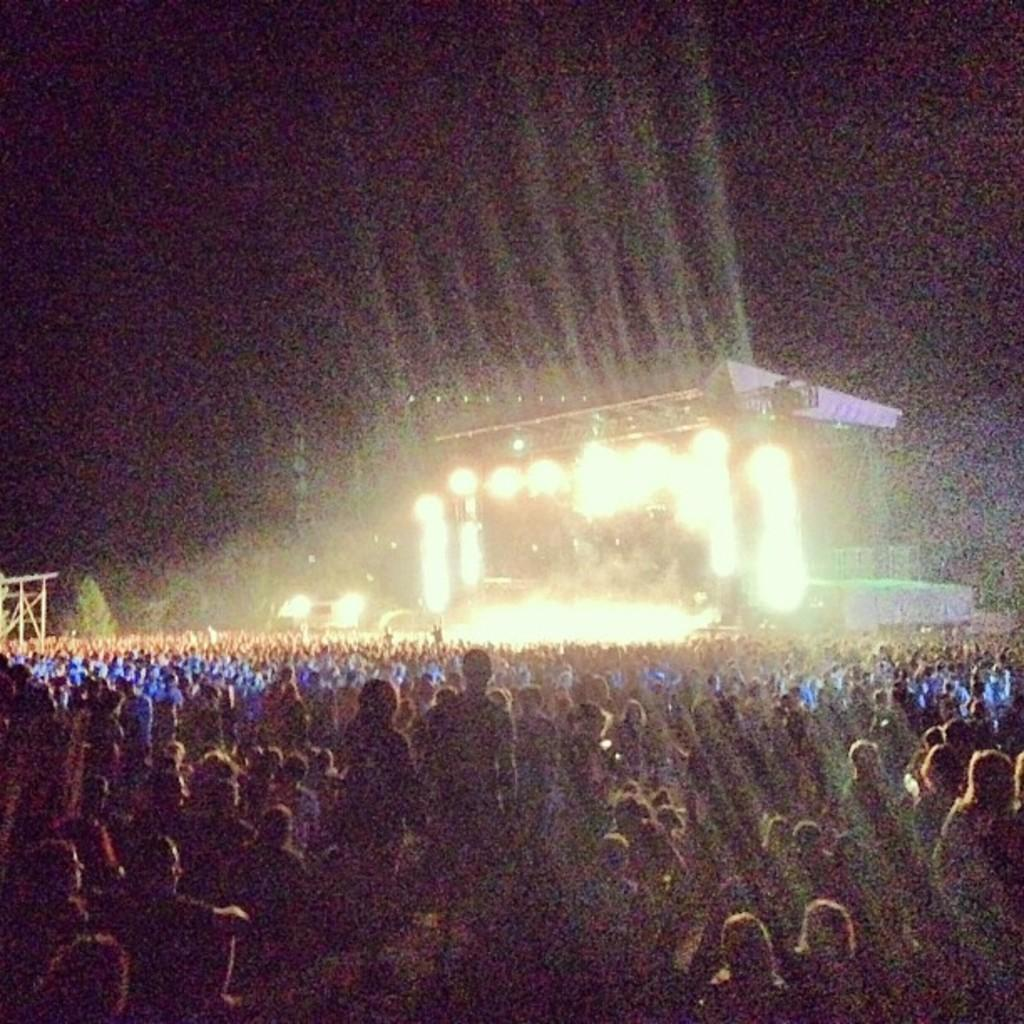What can be seen in the image involving people? There are people standing in the image. What type of illumination is present in the image? There are lights in the image. Can you describe the setting in the image? There is a setting in the image, which may provide context for the people and lights. What is visible in the background of the image? The sky is visible in the background of the image. What type of vegetation is present in the image? There is a tree in the image. What type of ink is being used by the minister in the image? There is no minister or ink present in the image. How does the acoustics of the setting affect the people in the image? The provided facts do not mention anything about the acoustics of the setting, so it cannot be determined how it affects the people in the image. 